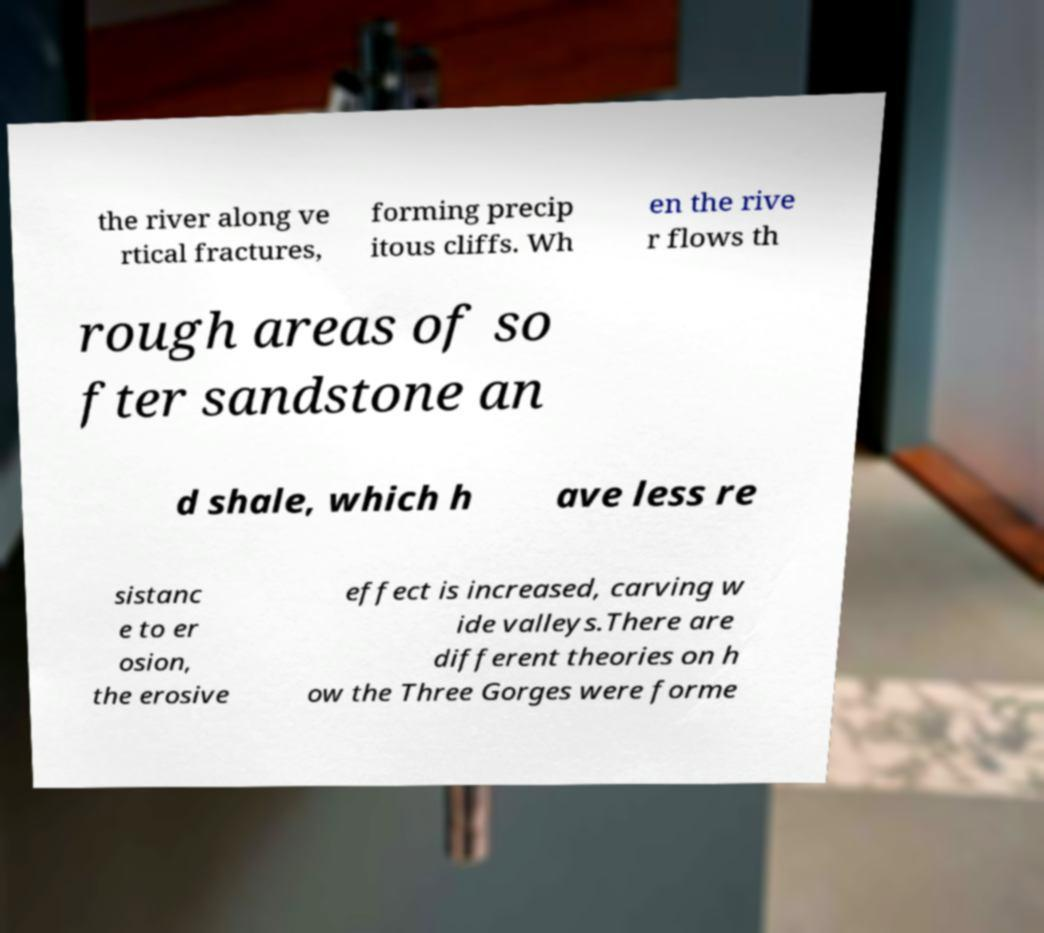Could you extract and type out the text from this image? the river along ve rtical fractures, forming precip itous cliffs. Wh en the rive r flows th rough areas of so fter sandstone an d shale, which h ave less re sistanc e to er osion, the erosive effect is increased, carving w ide valleys.There are different theories on h ow the Three Gorges were forme 